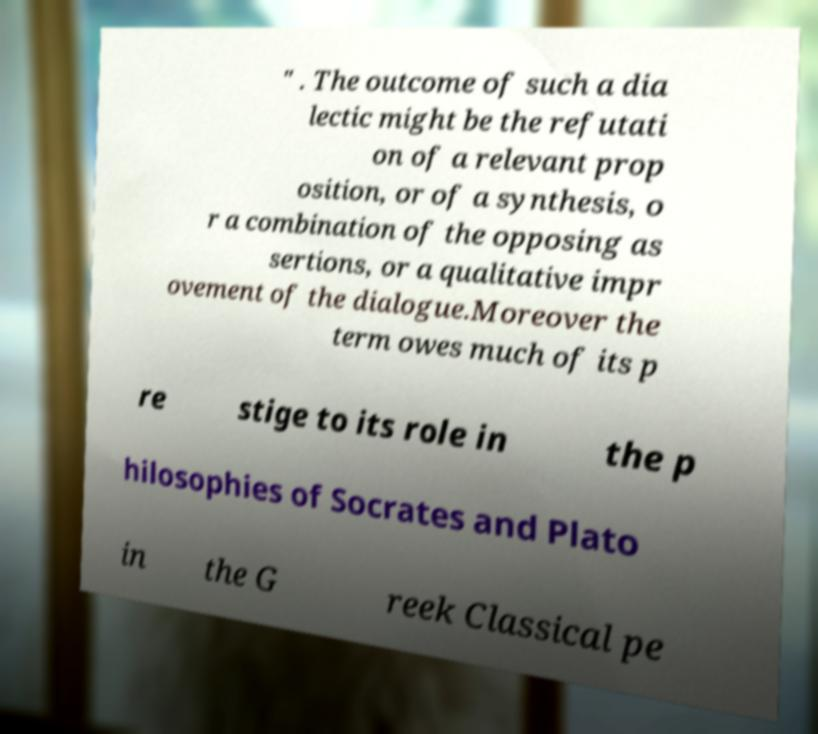Could you extract and type out the text from this image? " . The outcome of such a dia lectic might be the refutati on of a relevant prop osition, or of a synthesis, o r a combination of the opposing as sertions, or a qualitative impr ovement of the dialogue.Moreover the term owes much of its p re stige to its role in the p hilosophies of Socrates and Plato in the G reek Classical pe 